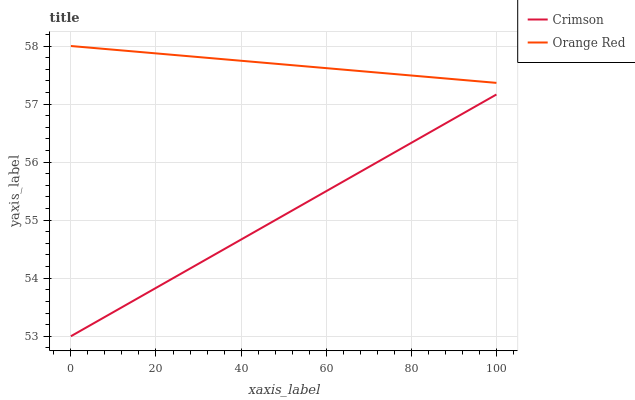Does Crimson have the minimum area under the curve?
Answer yes or no. Yes. Does Orange Red have the maximum area under the curve?
Answer yes or no. Yes. Does Orange Red have the minimum area under the curve?
Answer yes or no. No. Is Orange Red the smoothest?
Answer yes or no. Yes. Is Crimson the roughest?
Answer yes or no. Yes. Is Orange Red the roughest?
Answer yes or no. No. Does Crimson have the lowest value?
Answer yes or no. Yes. Does Orange Red have the lowest value?
Answer yes or no. No. Does Orange Red have the highest value?
Answer yes or no. Yes. Is Crimson less than Orange Red?
Answer yes or no. Yes. Is Orange Red greater than Crimson?
Answer yes or no. Yes. Does Crimson intersect Orange Red?
Answer yes or no. No. 